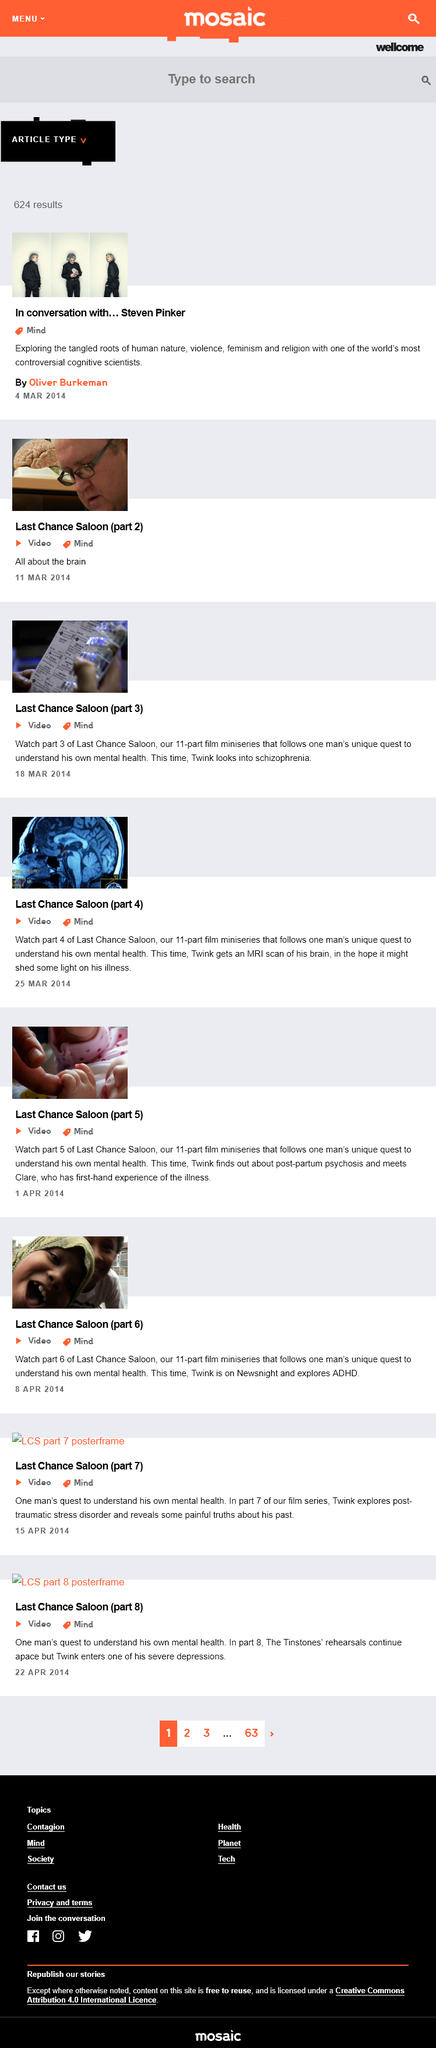Give some essential details in this illustration. It is determined that Twink requires an MRI scan of his brain. The video titled "Last Chance Saloon (part 4)" was uploaded on March 25, 2014. The topic of 'Last Chance Saloon (part 2)' is 'All about the brain,' as stated in the sentence. There are a total of 11 parts in the miniseries 'Last Chance Saloon'. Last Chance Saloon is a miniseries that delves into the journey of one man as he endeavors to comprehend his own mental health and well-being. 